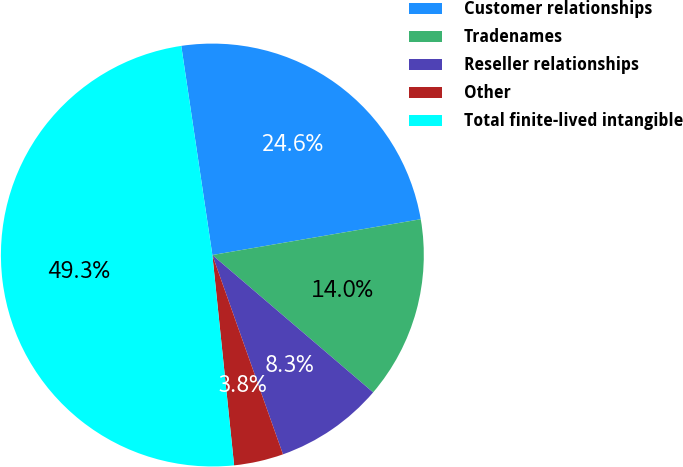Convert chart to OTSL. <chart><loc_0><loc_0><loc_500><loc_500><pie_chart><fcel>Customer relationships<fcel>Tradenames<fcel>Reseller relationships<fcel>Other<fcel>Total finite-lived intangible<nl><fcel>24.64%<fcel>13.96%<fcel>8.33%<fcel>3.78%<fcel>49.29%<nl></chart> 